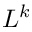<formula> <loc_0><loc_0><loc_500><loc_500>L ^ { k }</formula> 